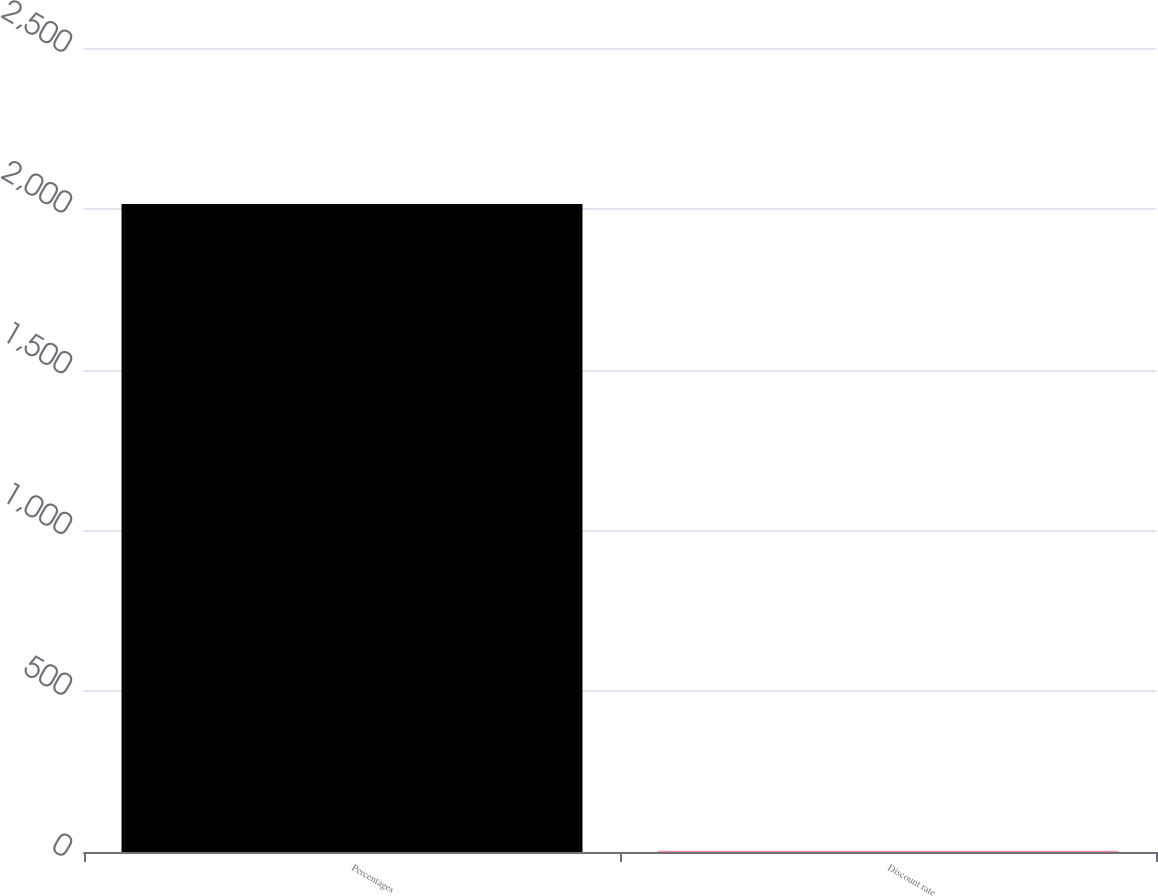<chart> <loc_0><loc_0><loc_500><loc_500><bar_chart><fcel>Percentages<fcel>Discount rate<nl><fcel>2015<fcel>3.74<nl></chart> 